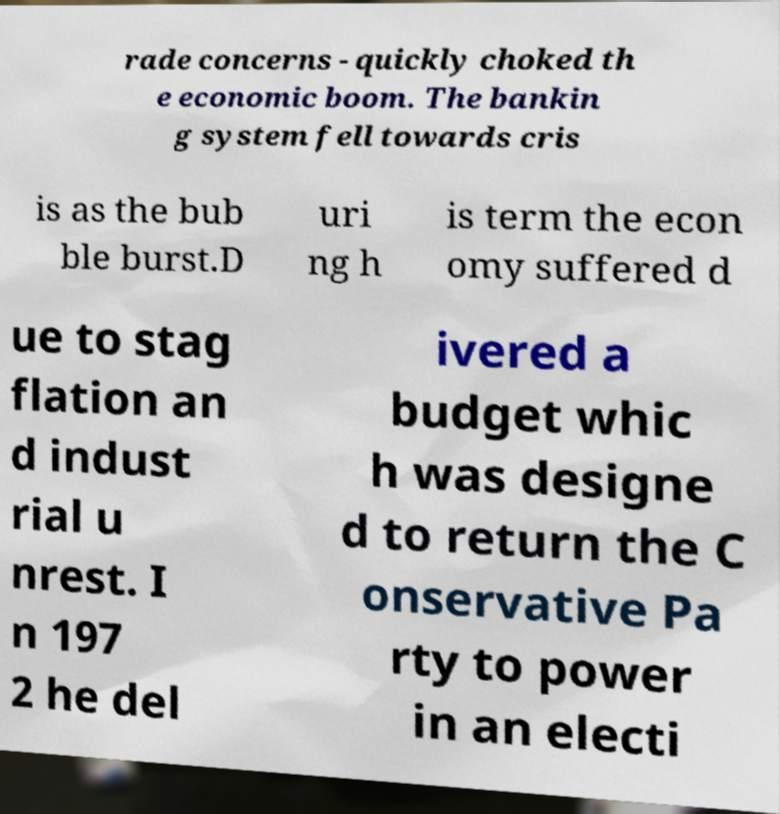Please read and relay the text visible in this image. What does it say? rade concerns - quickly choked th e economic boom. The bankin g system fell towards cris is as the bub ble burst.D uri ng h is term the econ omy suffered d ue to stag flation an d indust rial u nrest. I n 197 2 he del ivered a budget whic h was designe d to return the C onservative Pa rty to power in an electi 